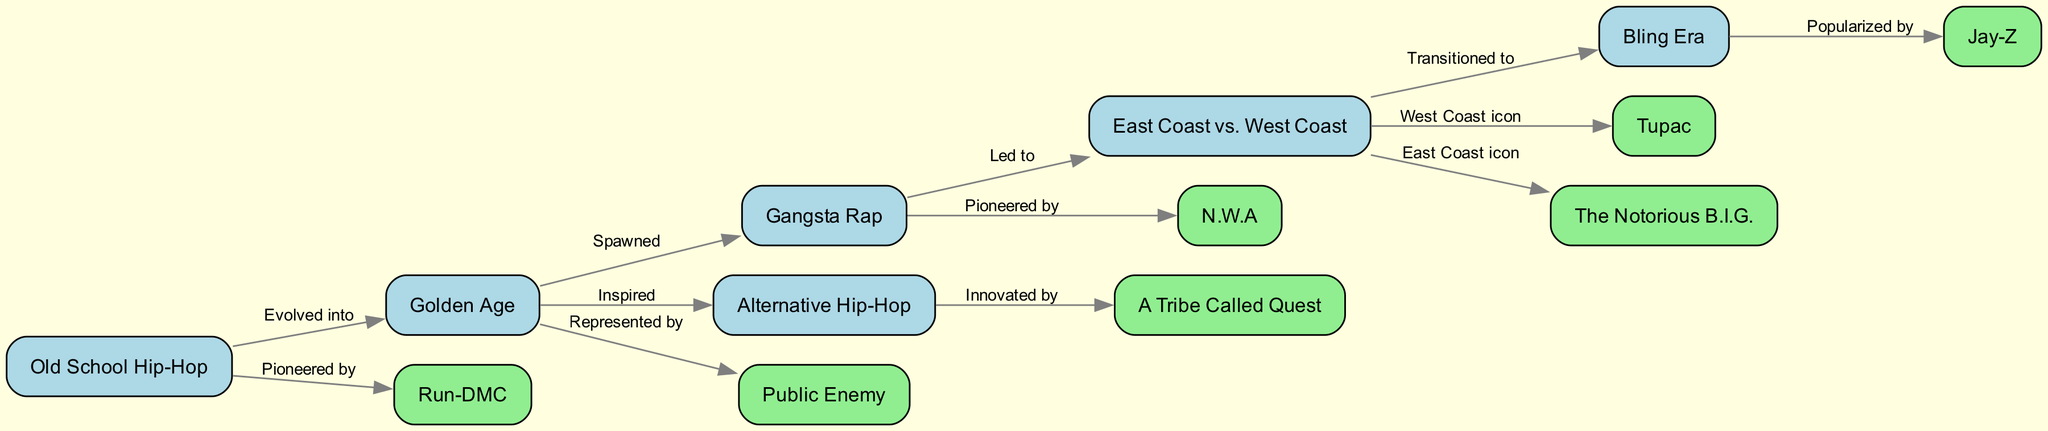What is the first node in the diagram? The first node listed is "Old School Hip-Hop," as it is the starting point for the evolution of hip-hop in the diagram.
Answer: Old School Hip-Hop How many main eras of hip-hop are depicted in the diagram? The diagram shows six main nodes representing different eras of hip-hop, as indicated by the labeled nodes from "Old School Hip-Hop" to "Bling Era."
Answer: Six Which artist is associated with "Gangsta Rap"? "N.W.A" is specifically mentioned as pioneering Gangsta Rap within the diagram's connections, showing the evolution and representation of this subgenre.
Answer: N.W.A What genre did the "Golden Age" inspire? "Alternative Hip-Hop" is labeled as inspired by the "Golden Age," indicating a direct connection in the genre evolution within the diagram.
Answer: Alternative Hip-Hop Who is the East Coast icon represented in the diagram? The diagram denotes "The Notorious B.I.G." as the East Coast icon, as shown in the connection with the "East Coast vs. West Coast" node.
Answer: The Notorious B.I.G Which era transitioned to the "Bling Era"? The "East Coast vs. West Coast" era led to the transition into the "Bling Era," indicating a significant shift in hip-hop style and culture.
Answer: East Coast vs. West Coast How did "Old School Hip-Hop" influence "Golden Age"? "Old School Hip-Hop" is labeled as having evolved into the "Golden Age," suggesting a progression in style, themes, and complexity in hip-hop music.
Answer: Evolved into What does "Public Enemy" represent in the diagram? "Public Enemy" is represented by the "Golden Age" in the diagram, emphasizing their significance during this influential period in hip-hop history.
Answer: Golden Age Which artist is popularized by the "Bling Era"? "Jay-Z" is marked as the artist who popularized the "Bling Era," showing his impact and influence during this particular phase in hip-hop evolution.
Answer: Jay-Z 